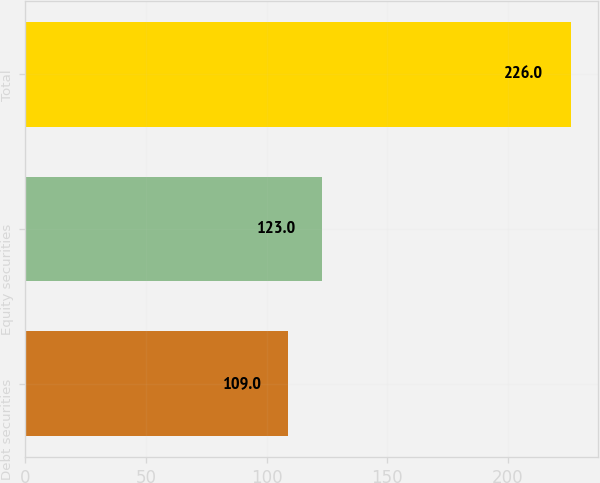Convert chart. <chart><loc_0><loc_0><loc_500><loc_500><bar_chart><fcel>Debt securities<fcel>Equity securities<fcel>Total<nl><fcel>109<fcel>123<fcel>226<nl></chart> 